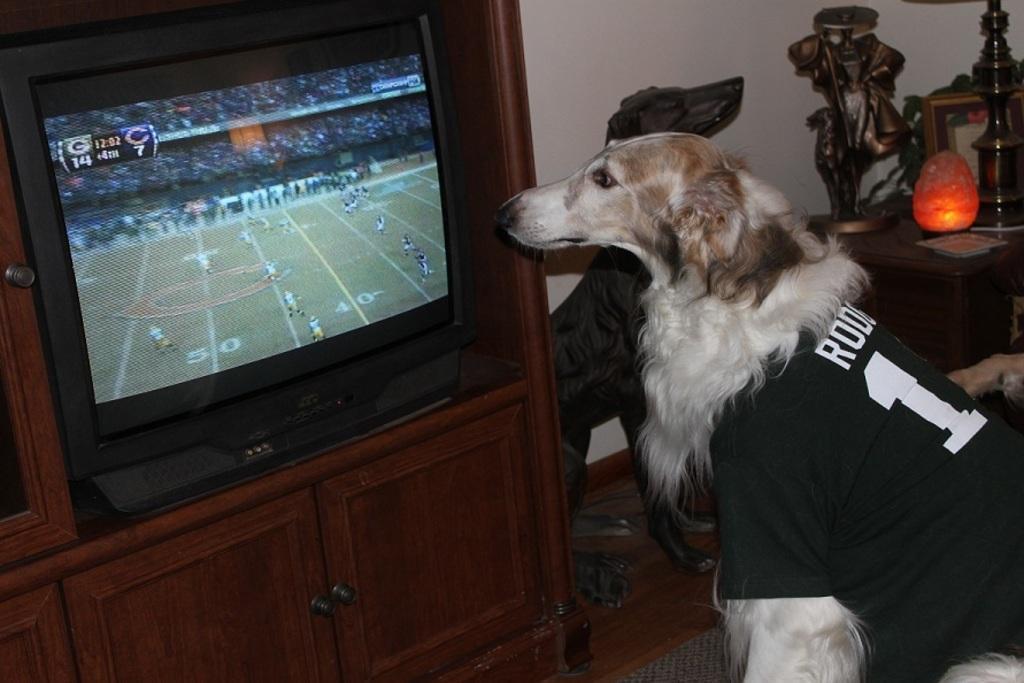In one or two sentences, can you explain what this image depicts? In this picture we can see a dog in front of the television, beside to the television we can find a light, frame and other things on the table. 